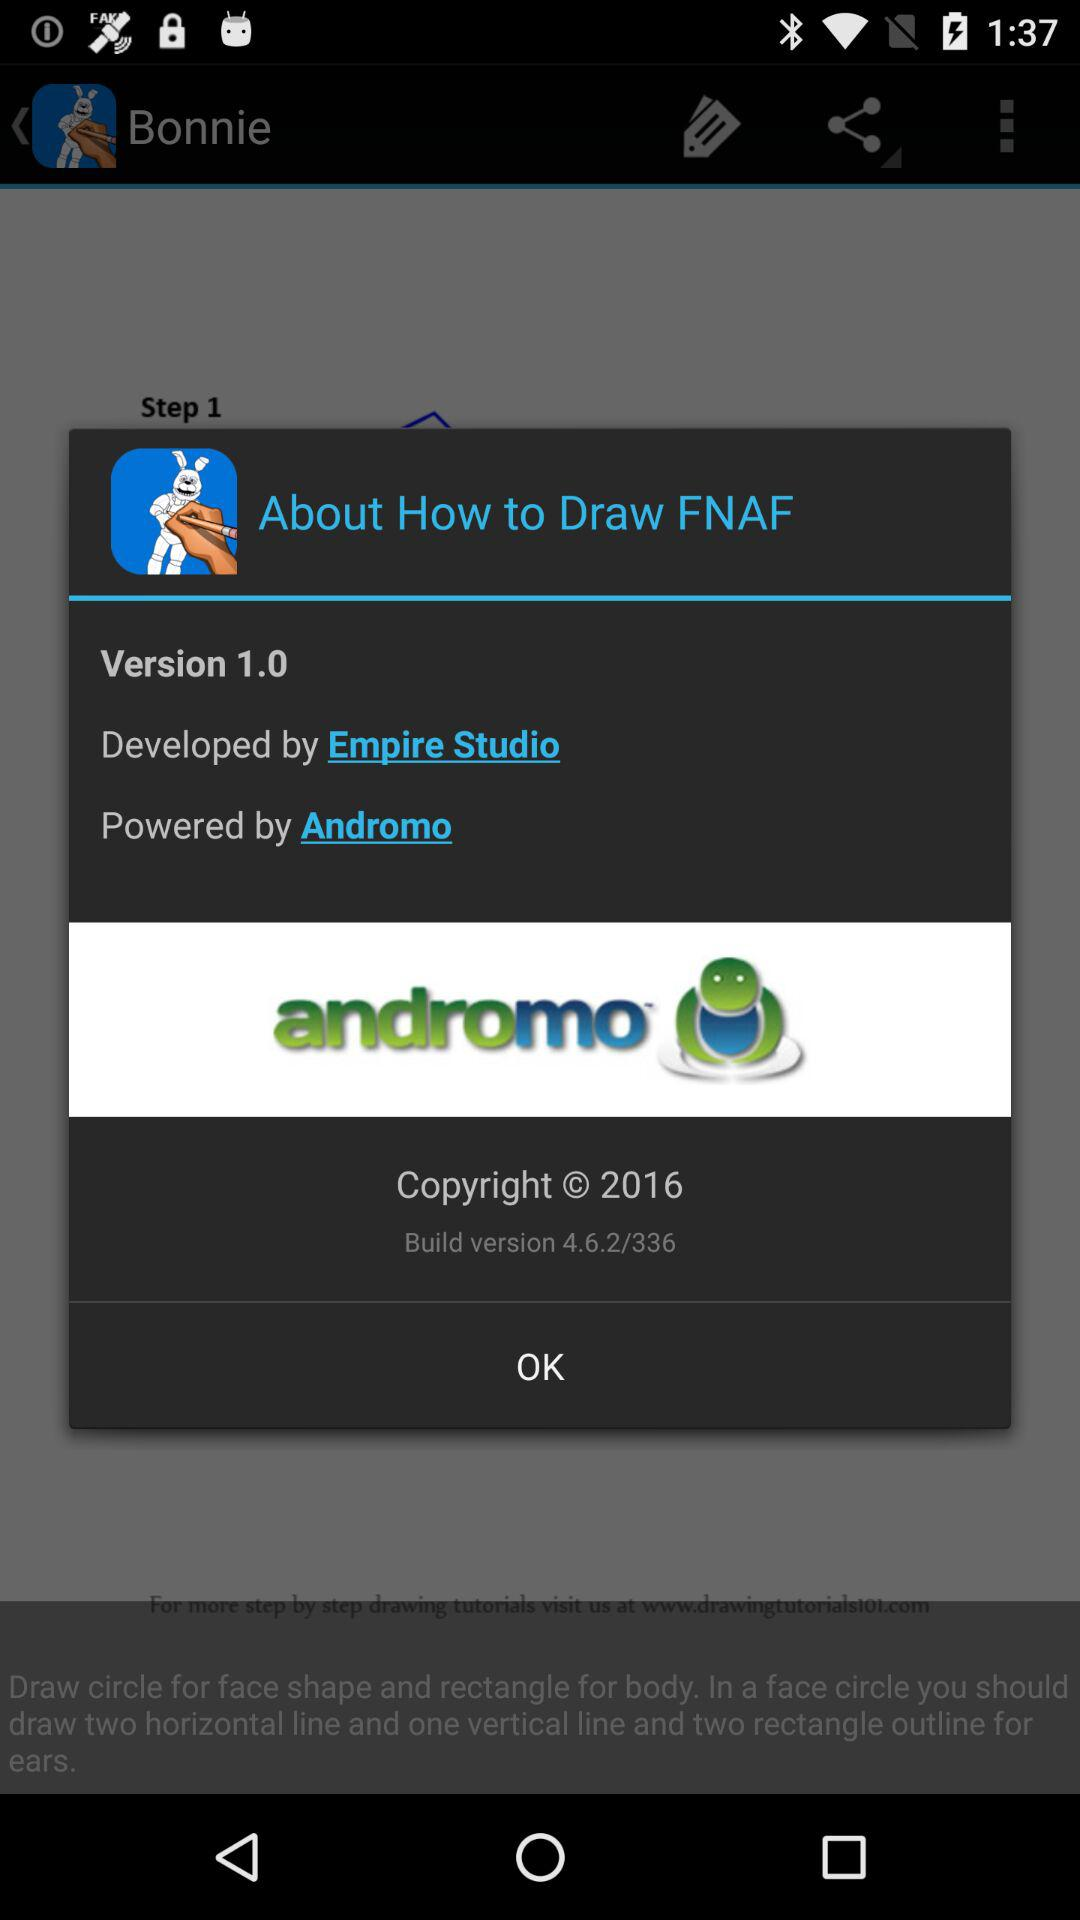Who powered "How to Draw FNAF"? "How to Draw FNAF" was powered by Andromo. 